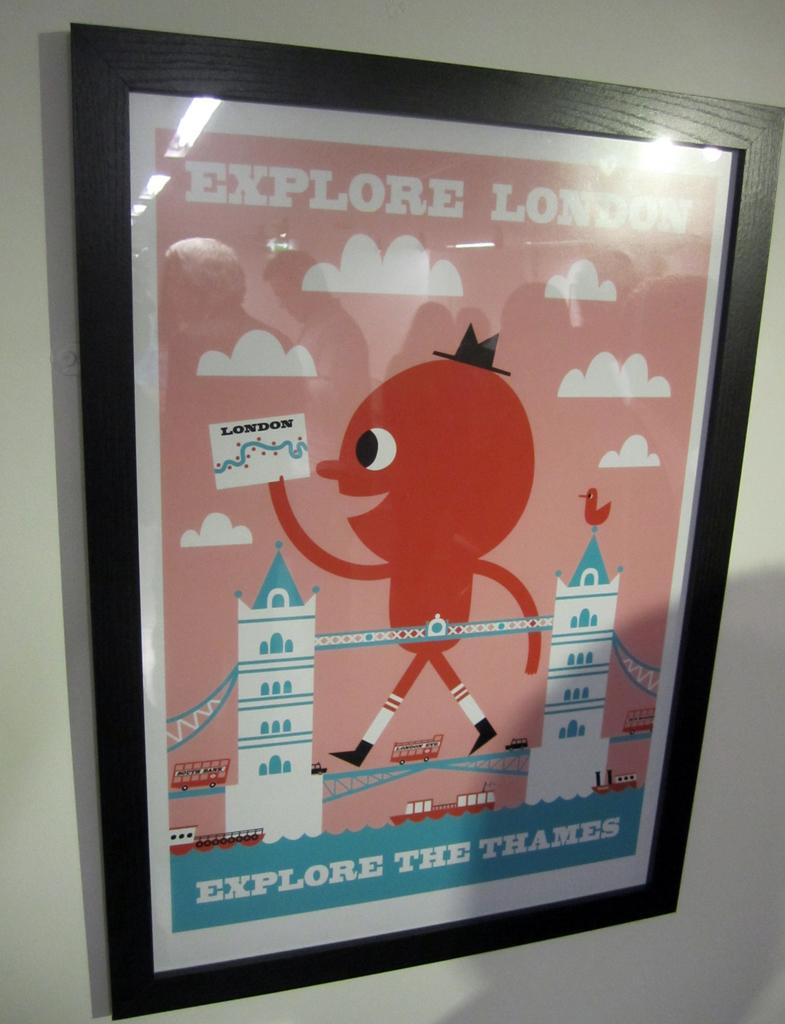What city is being talked about here?
Offer a terse response. London. 